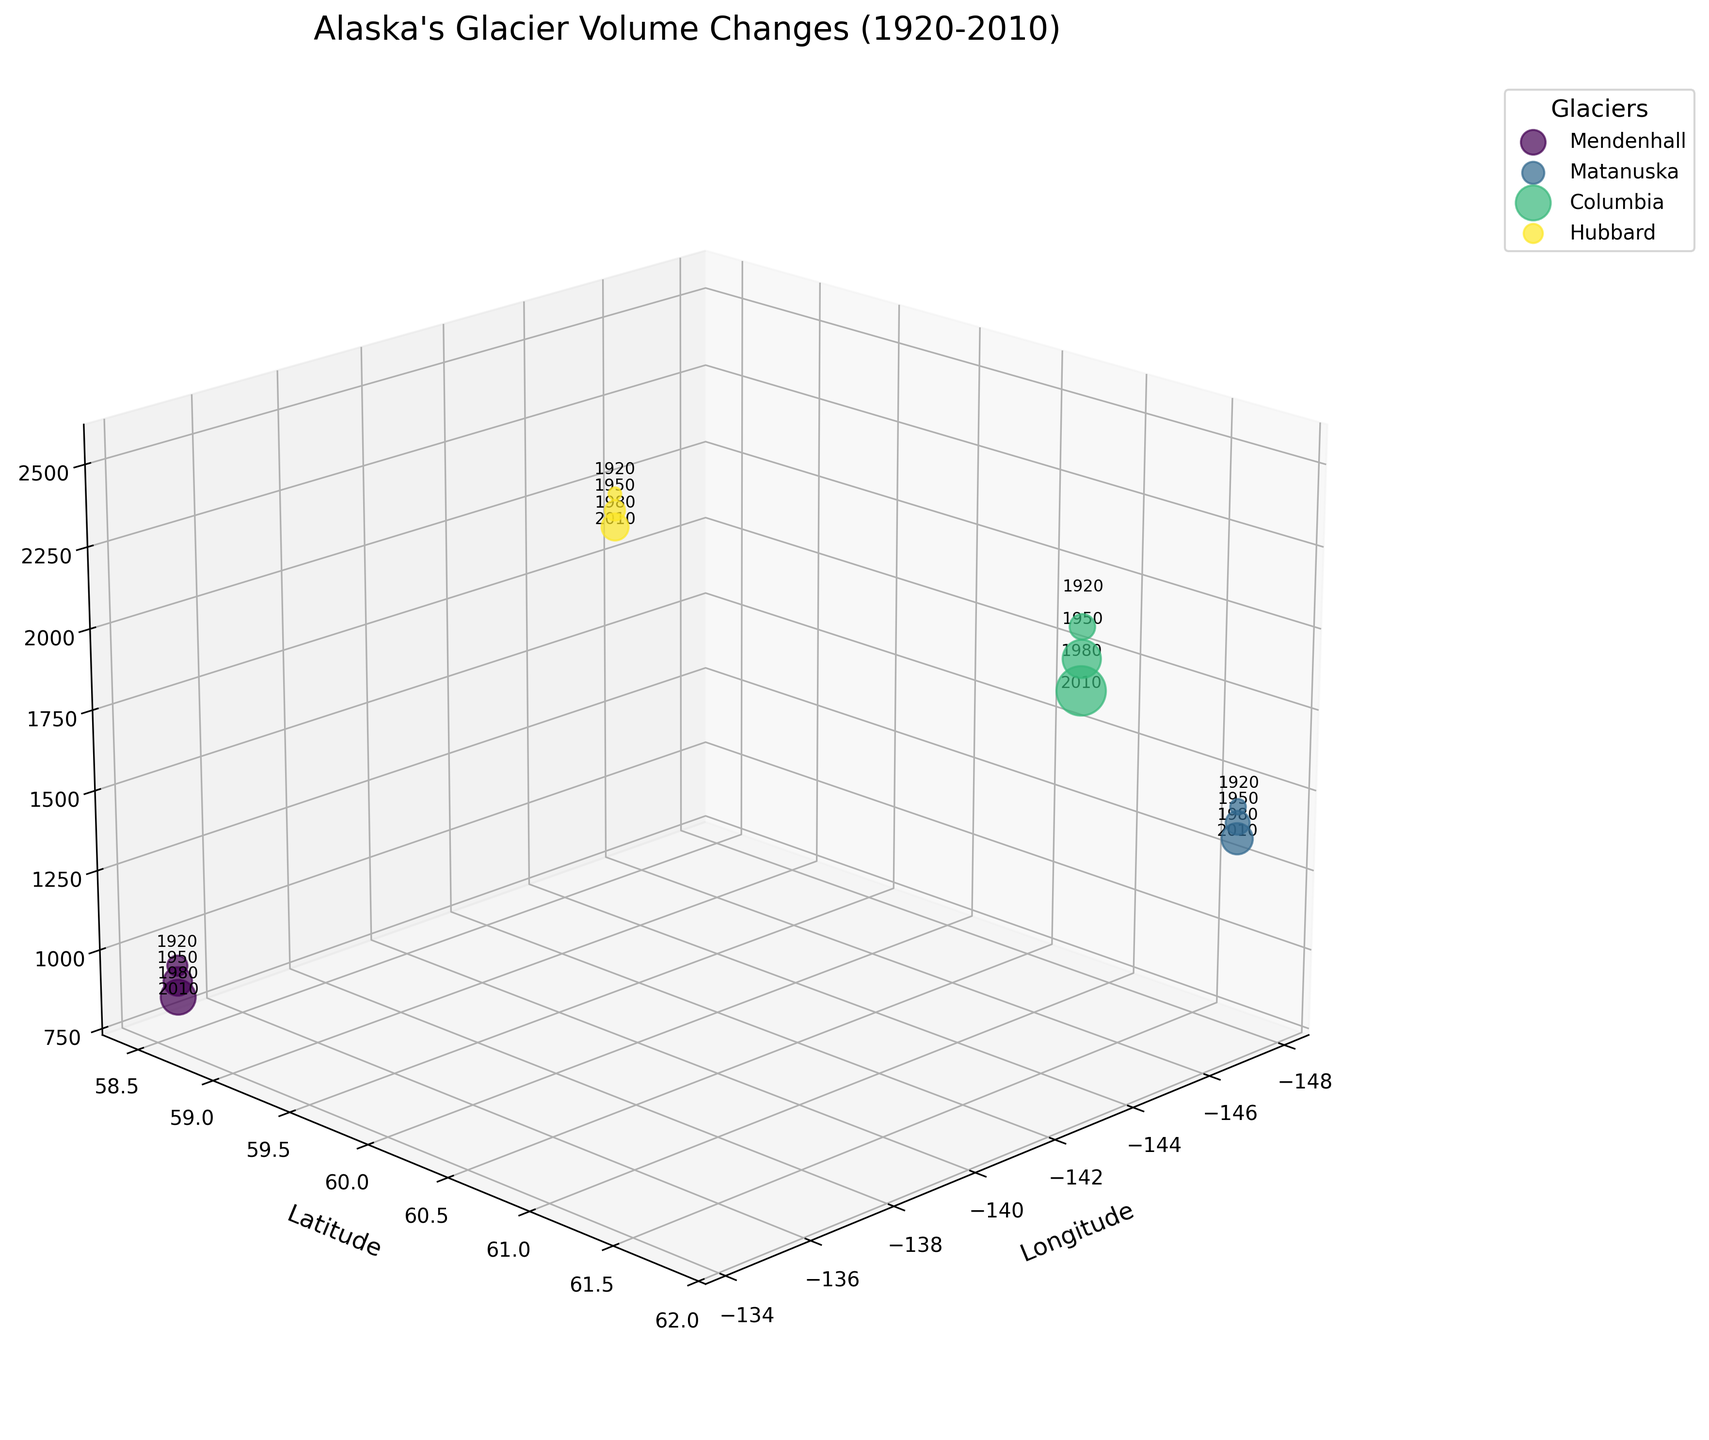What is the time range shown in the figure? The figure covers data points marked with years, which can be seen by the labels on the data points. The earliest year marked is 1920, and the latest is 2010.
Answer: 1920 to 2010 Which glacier experienced the highest volume loss by 2010? According to the figure, the sizes of the dots represent the magnitude of volume loss. The largest dot by 2010 corresponds to Columbia Glacier, which shows the highest ice loss.
Answer: Columbia What is the latitude and longitude of Mendenhall Glacier? The labels for Mendenhall Glacier show its location on the plot, with x and y axes representing longitude and latitude, respectively. For Mendenhall Glacier, the coordinates are specifically labeled, indicating its position as latitude 58.5 and longitude -134.5.
Answer: 58.5, -134.5 How did the elevation of Matanuska Glacier change over the century? By examining the coordinates of the plotted points for Matanuska Glacier across different years, one can observe that the elevation dropped progressively from 1500 meters in 1920 to 1350 meters in 2010.
Answer: Decreased from 1500m to 1350m Which glacier has the lowest volume loss recorded in 1950? Viewing the data points for the year 1950 and comparing their sizes, Hubbard Glacier has the smallest dot, indicating the least volume loss among all glaciers in that year.
Answer: Hubbard Name two glaciers that show a continuous decrease in both volume and elevation. By examining the trend of the points for each glacier across years, we can see that both Mendenhall and Matanuska Glaciers show a continuous decrease in both volume (size of points) and elevation (z-axis value).
Answer: Mendenhall, Matanuska By what magnitude did Columbia Glacier's volume change from 1920 to 2010? Columbia Glacier's data points show changes in volume, which are from 0 km³ in 1920 to -30 km³ in 2010. The magnitude of this change is 30 km³.
Answer: 30 km³ Which glacier had the highest elevation in 2010? Examining the z-axis values for the year 2010, Hubbard Glacier has the highest elevation of 2350 meters.
Answer: Hubbard 